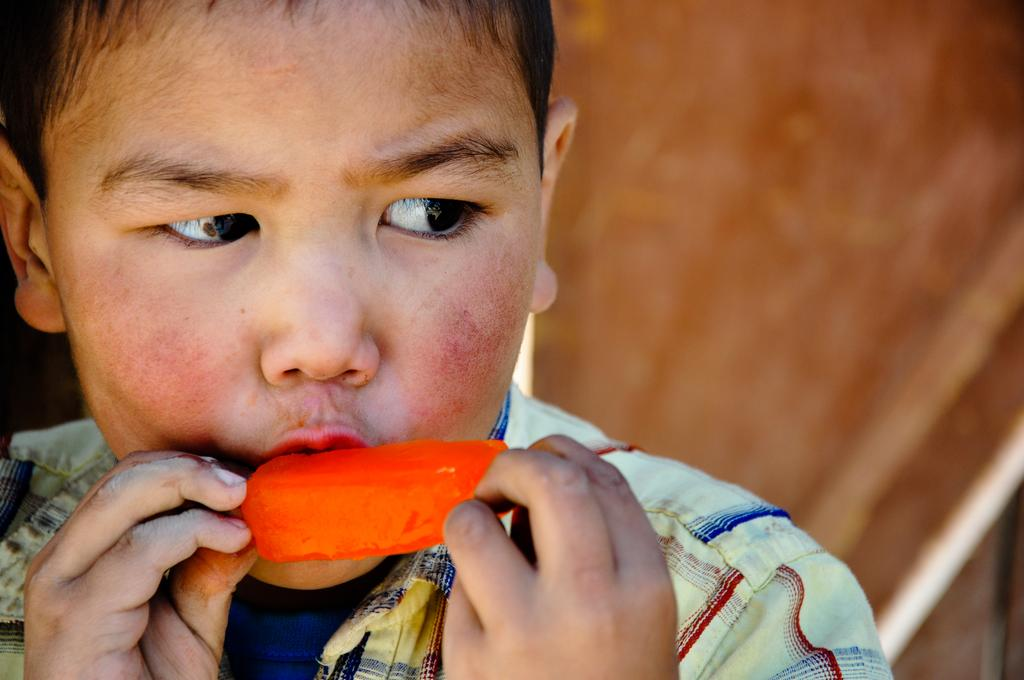Who is present in the image? There is a person in the image. What is the person doing in the image? The person is eating an ice cream. Where is the coat hanging in the image? There is no coat present in the image. What type of sponge is being used to clean the ice cream in the image? There is no sponge present in the image, and the person is eating the ice cream, not cleaning it. 